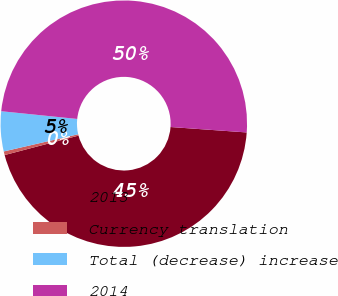<chart> <loc_0><loc_0><loc_500><loc_500><pie_chart><fcel>2013<fcel>Currency translation<fcel>Total (decrease) increase<fcel>2014<nl><fcel>44.77%<fcel>0.48%<fcel>5.23%<fcel>49.52%<nl></chart> 